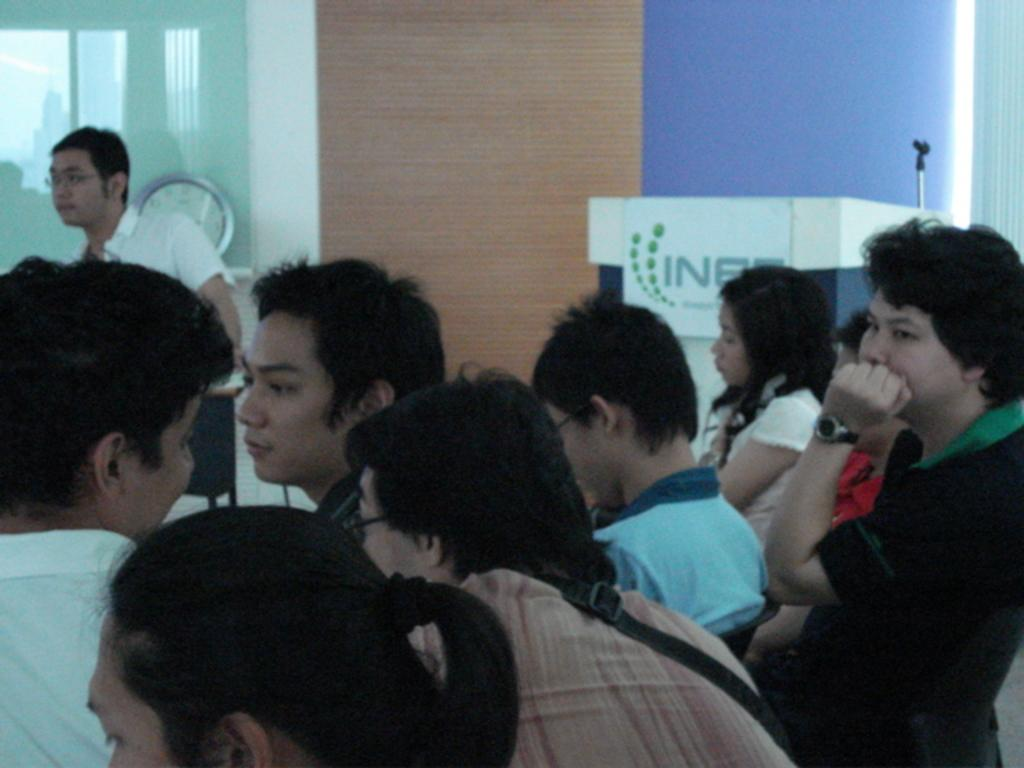What is the main subject in the foreground of the image? There is a crowd in the foreground of the image. What is the crowd doing in the image? The crowd is sitting. What can be seen in the background of the image? There is a man standing near a glass wall, a podium, and a mic stand in the background of the image. How many friends are visible in the image? There is no mention of friends in the image, so it is not possible to determine their presence or number. What type of gate can be seen in the image? There is no gate present in the image. 